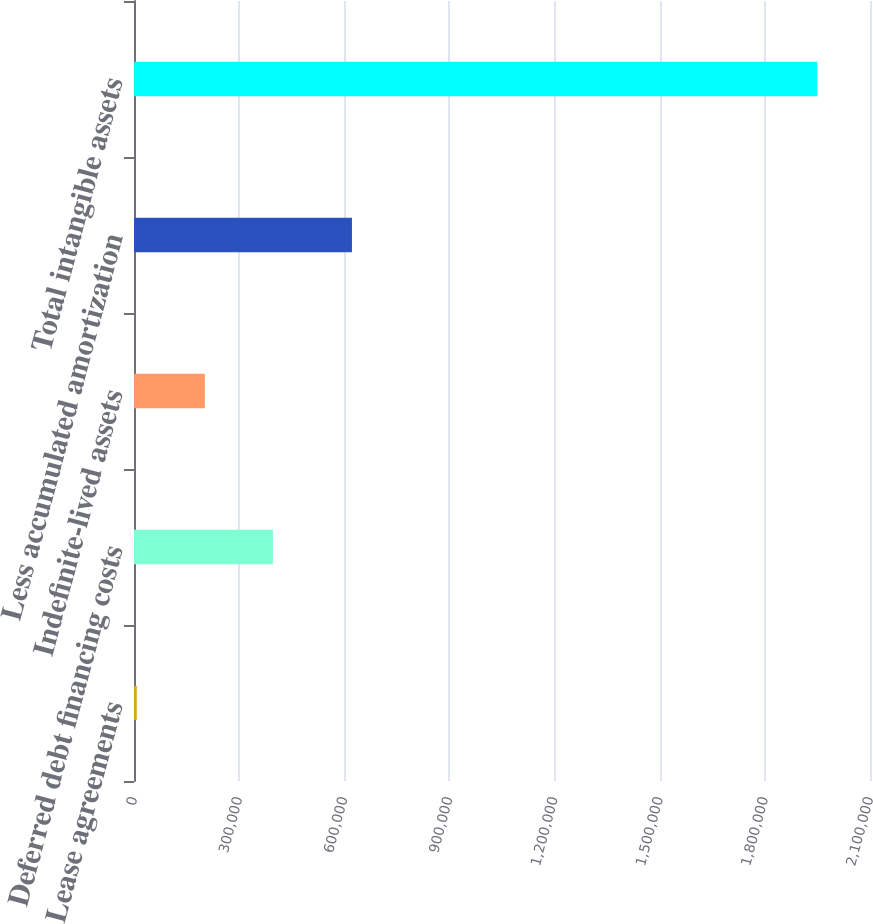<chart> <loc_0><loc_0><loc_500><loc_500><bar_chart><fcel>Lease agreements<fcel>Deferred debt financing costs<fcel>Indefinite-lived assets<fcel>Less accumulated amortization<fcel>Total intangible assets<nl><fcel>7982<fcel>396285<fcel>202134<fcel>621891<fcel>1.9495e+06<nl></chart> 